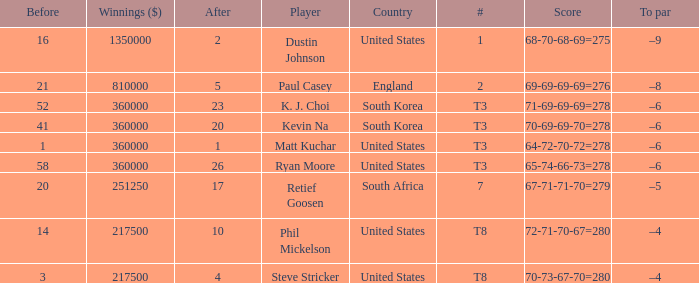How many times is  a to par listed when the player is phil mickelson? 1.0. 